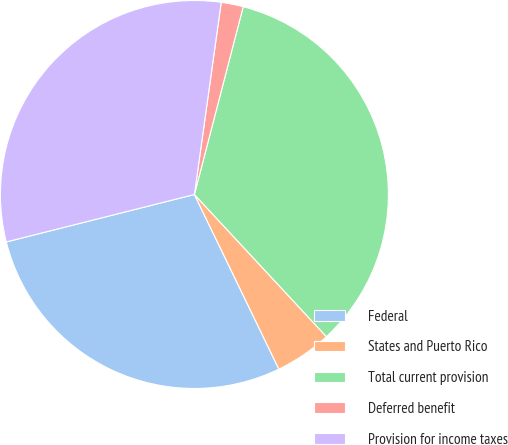Convert chart. <chart><loc_0><loc_0><loc_500><loc_500><pie_chart><fcel>Federal<fcel>States and Puerto Rico<fcel>Total current provision<fcel>Deferred benefit<fcel>Provision for income taxes<nl><fcel>28.24%<fcel>4.74%<fcel>34.04%<fcel>1.84%<fcel>31.14%<nl></chart> 